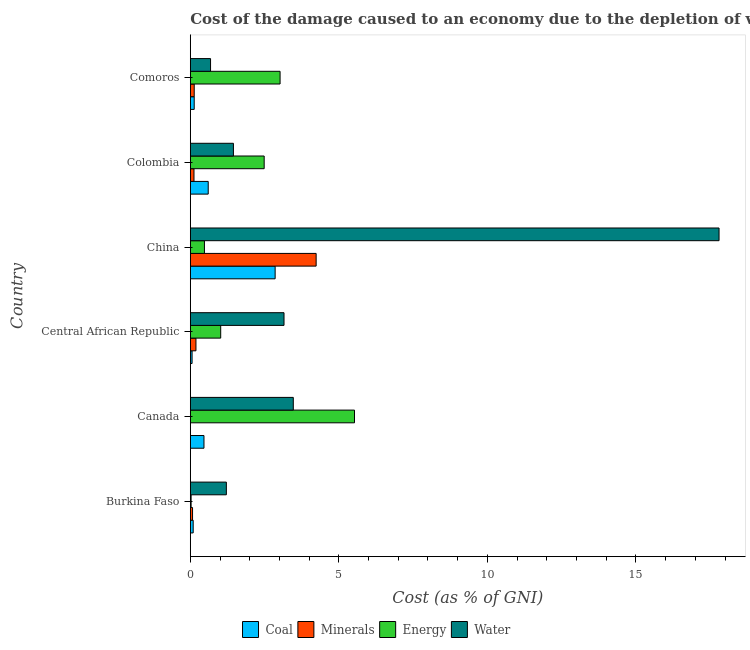How many bars are there on the 4th tick from the top?
Keep it short and to the point. 4. How many bars are there on the 3rd tick from the bottom?
Give a very brief answer. 4. What is the label of the 2nd group of bars from the top?
Your answer should be very brief. Colombia. What is the cost of damage due to depletion of minerals in Colombia?
Offer a terse response. 0.12. Across all countries, what is the maximum cost of damage due to depletion of energy?
Provide a succinct answer. 5.53. Across all countries, what is the minimum cost of damage due to depletion of energy?
Make the answer very short. 0.03. In which country was the cost of damage due to depletion of coal maximum?
Give a very brief answer. China. What is the total cost of damage due to depletion of energy in the graph?
Keep it short and to the point. 12.56. What is the difference between the cost of damage due to depletion of water in Canada and that in Colombia?
Keep it short and to the point. 2.02. What is the difference between the cost of damage due to depletion of water in Central African Republic and the cost of damage due to depletion of energy in Canada?
Keep it short and to the point. -2.37. What is the average cost of damage due to depletion of coal per country?
Make the answer very short. 0.7. What is the difference between the cost of damage due to depletion of energy and cost of damage due to depletion of water in Canada?
Ensure brevity in your answer.  2.06. What is the ratio of the cost of damage due to depletion of energy in China to that in Colombia?
Your response must be concise. 0.19. Is the difference between the cost of damage due to depletion of minerals in China and Colombia greater than the difference between the cost of damage due to depletion of water in China and Colombia?
Your answer should be compact. No. What is the difference between the highest and the second highest cost of damage due to depletion of coal?
Your answer should be compact. 2.25. What is the difference between the highest and the lowest cost of damage due to depletion of water?
Provide a short and direct response. 17.12. In how many countries, is the cost of damage due to depletion of energy greater than the average cost of damage due to depletion of energy taken over all countries?
Your answer should be very brief. 3. What does the 4th bar from the top in Comoros represents?
Offer a very short reply. Coal. What does the 4th bar from the bottom in Burkina Faso represents?
Provide a short and direct response. Water. Is it the case that in every country, the sum of the cost of damage due to depletion of coal and cost of damage due to depletion of minerals is greater than the cost of damage due to depletion of energy?
Your response must be concise. No. Are all the bars in the graph horizontal?
Your answer should be very brief. Yes. What is the difference between two consecutive major ticks on the X-axis?
Your answer should be very brief. 5. Does the graph contain any zero values?
Offer a terse response. No. How many legend labels are there?
Offer a terse response. 4. What is the title of the graph?
Keep it short and to the point. Cost of the damage caused to an economy due to the depletion of various resources in 1986 . What is the label or title of the X-axis?
Provide a short and direct response. Cost (as % of GNI). What is the label or title of the Y-axis?
Offer a terse response. Country. What is the Cost (as % of GNI) of Coal in Burkina Faso?
Your answer should be very brief. 0.1. What is the Cost (as % of GNI) in Minerals in Burkina Faso?
Provide a short and direct response. 0.08. What is the Cost (as % of GNI) in Energy in Burkina Faso?
Provide a short and direct response. 0.03. What is the Cost (as % of GNI) in Water in Burkina Faso?
Offer a very short reply. 1.21. What is the Cost (as % of GNI) in Coal in Canada?
Your answer should be very brief. 0.46. What is the Cost (as % of GNI) in Minerals in Canada?
Ensure brevity in your answer.  0. What is the Cost (as % of GNI) of Energy in Canada?
Your answer should be compact. 5.53. What is the Cost (as % of GNI) in Water in Canada?
Give a very brief answer. 3.47. What is the Cost (as % of GNI) of Coal in Central African Republic?
Offer a very short reply. 0.06. What is the Cost (as % of GNI) of Minerals in Central African Republic?
Provide a short and direct response. 0.19. What is the Cost (as % of GNI) of Energy in Central African Republic?
Keep it short and to the point. 1.02. What is the Cost (as % of GNI) in Water in Central African Republic?
Keep it short and to the point. 3.15. What is the Cost (as % of GNI) of Coal in China?
Your answer should be very brief. 2.86. What is the Cost (as % of GNI) in Minerals in China?
Your answer should be compact. 4.24. What is the Cost (as % of GNI) of Energy in China?
Keep it short and to the point. 0.48. What is the Cost (as % of GNI) in Water in China?
Offer a very short reply. 17.8. What is the Cost (as % of GNI) of Coal in Colombia?
Keep it short and to the point. 0.6. What is the Cost (as % of GNI) of Minerals in Colombia?
Your response must be concise. 0.12. What is the Cost (as % of GNI) of Energy in Colombia?
Ensure brevity in your answer.  2.49. What is the Cost (as % of GNI) of Water in Colombia?
Your response must be concise. 1.45. What is the Cost (as % of GNI) in Coal in Comoros?
Offer a very short reply. 0.13. What is the Cost (as % of GNI) of Minerals in Comoros?
Offer a terse response. 0.13. What is the Cost (as % of GNI) of Energy in Comoros?
Provide a short and direct response. 3.02. What is the Cost (as % of GNI) in Water in Comoros?
Offer a very short reply. 0.68. Across all countries, what is the maximum Cost (as % of GNI) of Coal?
Ensure brevity in your answer.  2.86. Across all countries, what is the maximum Cost (as % of GNI) in Minerals?
Offer a very short reply. 4.24. Across all countries, what is the maximum Cost (as % of GNI) of Energy?
Your response must be concise. 5.53. Across all countries, what is the maximum Cost (as % of GNI) of Water?
Your answer should be compact. 17.8. Across all countries, what is the minimum Cost (as % of GNI) of Coal?
Provide a short and direct response. 0.06. Across all countries, what is the minimum Cost (as % of GNI) of Minerals?
Offer a very short reply. 0. Across all countries, what is the minimum Cost (as % of GNI) of Energy?
Your answer should be very brief. 0.03. Across all countries, what is the minimum Cost (as % of GNI) of Water?
Make the answer very short. 0.68. What is the total Cost (as % of GNI) of Coal in the graph?
Make the answer very short. 4.21. What is the total Cost (as % of GNI) in Minerals in the graph?
Your response must be concise. 4.76. What is the total Cost (as % of GNI) in Energy in the graph?
Your response must be concise. 12.56. What is the total Cost (as % of GNI) of Water in the graph?
Your answer should be compact. 27.77. What is the difference between the Cost (as % of GNI) of Coal in Burkina Faso and that in Canada?
Offer a terse response. -0.36. What is the difference between the Cost (as % of GNI) of Minerals in Burkina Faso and that in Canada?
Offer a very short reply. 0.08. What is the difference between the Cost (as % of GNI) in Energy in Burkina Faso and that in Canada?
Offer a terse response. -5.5. What is the difference between the Cost (as % of GNI) in Water in Burkina Faso and that in Canada?
Provide a short and direct response. -2.25. What is the difference between the Cost (as % of GNI) of Coal in Burkina Faso and that in Central African Republic?
Make the answer very short. 0.04. What is the difference between the Cost (as % of GNI) in Minerals in Burkina Faso and that in Central African Republic?
Offer a very short reply. -0.11. What is the difference between the Cost (as % of GNI) of Energy in Burkina Faso and that in Central African Republic?
Your answer should be very brief. -1. What is the difference between the Cost (as % of GNI) of Water in Burkina Faso and that in Central African Republic?
Offer a terse response. -1.94. What is the difference between the Cost (as % of GNI) of Coal in Burkina Faso and that in China?
Ensure brevity in your answer.  -2.76. What is the difference between the Cost (as % of GNI) in Minerals in Burkina Faso and that in China?
Provide a short and direct response. -4.16. What is the difference between the Cost (as % of GNI) in Energy in Burkina Faso and that in China?
Ensure brevity in your answer.  -0.45. What is the difference between the Cost (as % of GNI) in Water in Burkina Faso and that in China?
Give a very brief answer. -16.58. What is the difference between the Cost (as % of GNI) in Coal in Burkina Faso and that in Colombia?
Give a very brief answer. -0.51. What is the difference between the Cost (as % of GNI) of Minerals in Burkina Faso and that in Colombia?
Offer a very short reply. -0.05. What is the difference between the Cost (as % of GNI) of Energy in Burkina Faso and that in Colombia?
Provide a short and direct response. -2.46. What is the difference between the Cost (as % of GNI) of Water in Burkina Faso and that in Colombia?
Your answer should be compact. -0.24. What is the difference between the Cost (as % of GNI) in Coal in Burkina Faso and that in Comoros?
Offer a terse response. -0.03. What is the difference between the Cost (as % of GNI) of Minerals in Burkina Faso and that in Comoros?
Keep it short and to the point. -0.06. What is the difference between the Cost (as % of GNI) of Energy in Burkina Faso and that in Comoros?
Your answer should be very brief. -2.99. What is the difference between the Cost (as % of GNI) in Water in Burkina Faso and that in Comoros?
Your response must be concise. 0.53. What is the difference between the Cost (as % of GNI) of Coal in Canada and that in Central African Republic?
Provide a succinct answer. 0.4. What is the difference between the Cost (as % of GNI) in Minerals in Canada and that in Central African Republic?
Offer a very short reply. -0.19. What is the difference between the Cost (as % of GNI) of Energy in Canada and that in Central African Republic?
Your answer should be compact. 4.5. What is the difference between the Cost (as % of GNI) in Water in Canada and that in Central African Republic?
Keep it short and to the point. 0.31. What is the difference between the Cost (as % of GNI) of Coal in Canada and that in China?
Offer a very short reply. -2.4. What is the difference between the Cost (as % of GNI) in Minerals in Canada and that in China?
Make the answer very short. -4.24. What is the difference between the Cost (as % of GNI) of Energy in Canada and that in China?
Give a very brief answer. 5.05. What is the difference between the Cost (as % of GNI) of Water in Canada and that in China?
Make the answer very short. -14.33. What is the difference between the Cost (as % of GNI) of Coal in Canada and that in Colombia?
Your answer should be very brief. -0.14. What is the difference between the Cost (as % of GNI) of Minerals in Canada and that in Colombia?
Give a very brief answer. -0.12. What is the difference between the Cost (as % of GNI) in Energy in Canada and that in Colombia?
Offer a very short reply. 3.04. What is the difference between the Cost (as % of GNI) in Water in Canada and that in Colombia?
Ensure brevity in your answer.  2.02. What is the difference between the Cost (as % of GNI) in Coal in Canada and that in Comoros?
Provide a short and direct response. 0.33. What is the difference between the Cost (as % of GNI) of Minerals in Canada and that in Comoros?
Keep it short and to the point. -0.13. What is the difference between the Cost (as % of GNI) of Energy in Canada and that in Comoros?
Make the answer very short. 2.5. What is the difference between the Cost (as % of GNI) in Water in Canada and that in Comoros?
Your response must be concise. 2.79. What is the difference between the Cost (as % of GNI) of Coal in Central African Republic and that in China?
Make the answer very short. -2.8. What is the difference between the Cost (as % of GNI) in Minerals in Central African Republic and that in China?
Ensure brevity in your answer.  -4.05. What is the difference between the Cost (as % of GNI) in Energy in Central African Republic and that in China?
Give a very brief answer. 0.55. What is the difference between the Cost (as % of GNI) in Water in Central African Republic and that in China?
Ensure brevity in your answer.  -14.64. What is the difference between the Cost (as % of GNI) in Coal in Central African Republic and that in Colombia?
Provide a short and direct response. -0.54. What is the difference between the Cost (as % of GNI) of Minerals in Central African Republic and that in Colombia?
Offer a very short reply. 0.07. What is the difference between the Cost (as % of GNI) in Energy in Central African Republic and that in Colombia?
Your answer should be very brief. -1.46. What is the difference between the Cost (as % of GNI) of Water in Central African Republic and that in Colombia?
Your answer should be compact. 1.7. What is the difference between the Cost (as % of GNI) of Coal in Central African Republic and that in Comoros?
Offer a very short reply. -0.07. What is the difference between the Cost (as % of GNI) in Minerals in Central African Republic and that in Comoros?
Ensure brevity in your answer.  0.06. What is the difference between the Cost (as % of GNI) of Energy in Central African Republic and that in Comoros?
Your answer should be compact. -2. What is the difference between the Cost (as % of GNI) of Water in Central African Republic and that in Comoros?
Your response must be concise. 2.47. What is the difference between the Cost (as % of GNI) of Coal in China and that in Colombia?
Keep it short and to the point. 2.25. What is the difference between the Cost (as % of GNI) in Minerals in China and that in Colombia?
Ensure brevity in your answer.  4.11. What is the difference between the Cost (as % of GNI) of Energy in China and that in Colombia?
Your answer should be very brief. -2.01. What is the difference between the Cost (as % of GNI) of Water in China and that in Colombia?
Offer a terse response. 16.35. What is the difference between the Cost (as % of GNI) in Coal in China and that in Comoros?
Provide a succinct answer. 2.72. What is the difference between the Cost (as % of GNI) of Minerals in China and that in Comoros?
Offer a terse response. 4.1. What is the difference between the Cost (as % of GNI) in Energy in China and that in Comoros?
Provide a short and direct response. -2.55. What is the difference between the Cost (as % of GNI) in Water in China and that in Comoros?
Give a very brief answer. 17.12. What is the difference between the Cost (as % of GNI) of Coal in Colombia and that in Comoros?
Your answer should be compact. 0.47. What is the difference between the Cost (as % of GNI) of Minerals in Colombia and that in Comoros?
Your answer should be compact. -0.01. What is the difference between the Cost (as % of GNI) of Energy in Colombia and that in Comoros?
Offer a very short reply. -0.54. What is the difference between the Cost (as % of GNI) in Water in Colombia and that in Comoros?
Offer a very short reply. 0.77. What is the difference between the Cost (as % of GNI) of Coal in Burkina Faso and the Cost (as % of GNI) of Minerals in Canada?
Provide a succinct answer. 0.1. What is the difference between the Cost (as % of GNI) in Coal in Burkina Faso and the Cost (as % of GNI) in Energy in Canada?
Give a very brief answer. -5.43. What is the difference between the Cost (as % of GNI) of Coal in Burkina Faso and the Cost (as % of GNI) of Water in Canada?
Your answer should be very brief. -3.37. What is the difference between the Cost (as % of GNI) in Minerals in Burkina Faso and the Cost (as % of GNI) in Energy in Canada?
Provide a short and direct response. -5.45. What is the difference between the Cost (as % of GNI) in Minerals in Burkina Faso and the Cost (as % of GNI) in Water in Canada?
Your answer should be very brief. -3.39. What is the difference between the Cost (as % of GNI) of Energy in Burkina Faso and the Cost (as % of GNI) of Water in Canada?
Your answer should be very brief. -3.44. What is the difference between the Cost (as % of GNI) of Coal in Burkina Faso and the Cost (as % of GNI) of Minerals in Central African Republic?
Your response must be concise. -0.09. What is the difference between the Cost (as % of GNI) in Coal in Burkina Faso and the Cost (as % of GNI) in Energy in Central African Republic?
Offer a very short reply. -0.93. What is the difference between the Cost (as % of GNI) of Coal in Burkina Faso and the Cost (as % of GNI) of Water in Central African Republic?
Your answer should be compact. -3.06. What is the difference between the Cost (as % of GNI) in Minerals in Burkina Faso and the Cost (as % of GNI) in Energy in Central African Republic?
Provide a short and direct response. -0.95. What is the difference between the Cost (as % of GNI) of Minerals in Burkina Faso and the Cost (as % of GNI) of Water in Central African Republic?
Offer a very short reply. -3.08. What is the difference between the Cost (as % of GNI) of Energy in Burkina Faso and the Cost (as % of GNI) of Water in Central African Republic?
Provide a succinct answer. -3.13. What is the difference between the Cost (as % of GNI) of Coal in Burkina Faso and the Cost (as % of GNI) of Minerals in China?
Your response must be concise. -4.14. What is the difference between the Cost (as % of GNI) of Coal in Burkina Faso and the Cost (as % of GNI) of Energy in China?
Your response must be concise. -0.38. What is the difference between the Cost (as % of GNI) in Coal in Burkina Faso and the Cost (as % of GNI) in Water in China?
Your answer should be compact. -17.7. What is the difference between the Cost (as % of GNI) of Minerals in Burkina Faso and the Cost (as % of GNI) of Energy in China?
Your response must be concise. -0.4. What is the difference between the Cost (as % of GNI) in Minerals in Burkina Faso and the Cost (as % of GNI) in Water in China?
Make the answer very short. -17.72. What is the difference between the Cost (as % of GNI) of Energy in Burkina Faso and the Cost (as % of GNI) of Water in China?
Offer a terse response. -17.77. What is the difference between the Cost (as % of GNI) in Coal in Burkina Faso and the Cost (as % of GNI) in Minerals in Colombia?
Provide a succinct answer. -0.03. What is the difference between the Cost (as % of GNI) in Coal in Burkina Faso and the Cost (as % of GNI) in Energy in Colombia?
Your answer should be very brief. -2.39. What is the difference between the Cost (as % of GNI) of Coal in Burkina Faso and the Cost (as % of GNI) of Water in Colombia?
Ensure brevity in your answer.  -1.35. What is the difference between the Cost (as % of GNI) of Minerals in Burkina Faso and the Cost (as % of GNI) of Energy in Colombia?
Make the answer very short. -2.41. What is the difference between the Cost (as % of GNI) of Minerals in Burkina Faso and the Cost (as % of GNI) of Water in Colombia?
Make the answer very short. -1.38. What is the difference between the Cost (as % of GNI) in Energy in Burkina Faso and the Cost (as % of GNI) in Water in Colombia?
Provide a short and direct response. -1.42. What is the difference between the Cost (as % of GNI) in Coal in Burkina Faso and the Cost (as % of GNI) in Minerals in Comoros?
Keep it short and to the point. -0.03. What is the difference between the Cost (as % of GNI) in Coal in Burkina Faso and the Cost (as % of GNI) in Energy in Comoros?
Your response must be concise. -2.92. What is the difference between the Cost (as % of GNI) of Coal in Burkina Faso and the Cost (as % of GNI) of Water in Comoros?
Your answer should be compact. -0.58. What is the difference between the Cost (as % of GNI) of Minerals in Burkina Faso and the Cost (as % of GNI) of Energy in Comoros?
Your answer should be very brief. -2.95. What is the difference between the Cost (as % of GNI) of Minerals in Burkina Faso and the Cost (as % of GNI) of Water in Comoros?
Keep it short and to the point. -0.61. What is the difference between the Cost (as % of GNI) of Energy in Burkina Faso and the Cost (as % of GNI) of Water in Comoros?
Offer a very short reply. -0.65. What is the difference between the Cost (as % of GNI) of Coal in Canada and the Cost (as % of GNI) of Minerals in Central African Republic?
Provide a succinct answer. 0.27. What is the difference between the Cost (as % of GNI) of Coal in Canada and the Cost (as % of GNI) of Energy in Central African Republic?
Ensure brevity in your answer.  -0.56. What is the difference between the Cost (as % of GNI) in Coal in Canada and the Cost (as % of GNI) in Water in Central African Republic?
Your answer should be compact. -2.69. What is the difference between the Cost (as % of GNI) in Minerals in Canada and the Cost (as % of GNI) in Energy in Central African Republic?
Give a very brief answer. -1.02. What is the difference between the Cost (as % of GNI) of Minerals in Canada and the Cost (as % of GNI) of Water in Central African Republic?
Your response must be concise. -3.15. What is the difference between the Cost (as % of GNI) in Energy in Canada and the Cost (as % of GNI) in Water in Central African Republic?
Make the answer very short. 2.37. What is the difference between the Cost (as % of GNI) in Coal in Canada and the Cost (as % of GNI) in Minerals in China?
Your answer should be very brief. -3.78. What is the difference between the Cost (as % of GNI) in Coal in Canada and the Cost (as % of GNI) in Energy in China?
Provide a succinct answer. -0.02. What is the difference between the Cost (as % of GNI) in Coal in Canada and the Cost (as % of GNI) in Water in China?
Provide a short and direct response. -17.34. What is the difference between the Cost (as % of GNI) of Minerals in Canada and the Cost (as % of GNI) of Energy in China?
Provide a succinct answer. -0.48. What is the difference between the Cost (as % of GNI) of Minerals in Canada and the Cost (as % of GNI) of Water in China?
Offer a terse response. -17.8. What is the difference between the Cost (as % of GNI) in Energy in Canada and the Cost (as % of GNI) in Water in China?
Make the answer very short. -12.27. What is the difference between the Cost (as % of GNI) of Coal in Canada and the Cost (as % of GNI) of Minerals in Colombia?
Keep it short and to the point. 0.34. What is the difference between the Cost (as % of GNI) of Coal in Canada and the Cost (as % of GNI) of Energy in Colombia?
Ensure brevity in your answer.  -2.03. What is the difference between the Cost (as % of GNI) of Coal in Canada and the Cost (as % of GNI) of Water in Colombia?
Offer a terse response. -0.99. What is the difference between the Cost (as % of GNI) of Minerals in Canada and the Cost (as % of GNI) of Energy in Colombia?
Provide a succinct answer. -2.49. What is the difference between the Cost (as % of GNI) of Minerals in Canada and the Cost (as % of GNI) of Water in Colombia?
Make the answer very short. -1.45. What is the difference between the Cost (as % of GNI) in Energy in Canada and the Cost (as % of GNI) in Water in Colombia?
Keep it short and to the point. 4.08. What is the difference between the Cost (as % of GNI) in Coal in Canada and the Cost (as % of GNI) in Minerals in Comoros?
Provide a short and direct response. 0.33. What is the difference between the Cost (as % of GNI) of Coal in Canada and the Cost (as % of GNI) of Energy in Comoros?
Your response must be concise. -2.56. What is the difference between the Cost (as % of GNI) in Coal in Canada and the Cost (as % of GNI) in Water in Comoros?
Your answer should be very brief. -0.22. What is the difference between the Cost (as % of GNI) of Minerals in Canada and the Cost (as % of GNI) of Energy in Comoros?
Provide a succinct answer. -3.02. What is the difference between the Cost (as % of GNI) in Minerals in Canada and the Cost (as % of GNI) in Water in Comoros?
Give a very brief answer. -0.68. What is the difference between the Cost (as % of GNI) of Energy in Canada and the Cost (as % of GNI) of Water in Comoros?
Offer a terse response. 4.85. What is the difference between the Cost (as % of GNI) of Coal in Central African Republic and the Cost (as % of GNI) of Minerals in China?
Your answer should be compact. -4.18. What is the difference between the Cost (as % of GNI) of Coal in Central African Republic and the Cost (as % of GNI) of Energy in China?
Keep it short and to the point. -0.42. What is the difference between the Cost (as % of GNI) of Coal in Central African Republic and the Cost (as % of GNI) of Water in China?
Give a very brief answer. -17.74. What is the difference between the Cost (as % of GNI) of Minerals in Central African Republic and the Cost (as % of GNI) of Energy in China?
Give a very brief answer. -0.29. What is the difference between the Cost (as % of GNI) in Minerals in Central African Republic and the Cost (as % of GNI) in Water in China?
Provide a short and direct response. -17.61. What is the difference between the Cost (as % of GNI) of Energy in Central African Republic and the Cost (as % of GNI) of Water in China?
Offer a terse response. -16.77. What is the difference between the Cost (as % of GNI) of Coal in Central African Republic and the Cost (as % of GNI) of Minerals in Colombia?
Provide a succinct answer. -0.06. What is the difference between the Cost (as % of GNI) in Coal in Central African Republic and the Cost (as % of GNI) in Energy in Colombia?
Keep it short and to the point. -2.43. What is the difference between the Cost (as % of GNI) of Coal in Central African Republic and the Cost (as % of GNI) of Water in Colombia?
Your response must be concise. -1.39. What is the difference between the Cost (as % of GNI) in Minerals in Central African Republic and the Cost (as % of GNI) in Energy in Colombia?
Provide a succinct answer. -2.3. What is the difference between the Cost (as % of GNI) in Minerals in Central African Republic and the Cost (as % of GNI) in Water in Colombia?
Offer a terse response. -1.26. What is the difference between the Cost (as % of GNI) of Energy in Central African Republic and the Cost (as % of GNI) of Water in Colombia?
Keep it short and to the point. -0.43. What is the difference between the Cost (as % of GNI) in Coal in Central African Republic and the Cost (as % of GNI) in Minerals in Comoros?
Your answer should be compact. -0.07. What is the difference between the Cost (as % of GNI) in Coal in Central African Republic and the Cost (as % of GNI) in Energy in Comoros?
Keep it short and to the point. -2.96. What is the difference between the Cost (as % of GNI) of Coal in Central African Republic and the Cost (as % of GNI) of Water in Comoros?
Make the answer very short. -0.62. What is the difference between the Cost (as % of GNI) in Minerals in Central African Republic and the Cost (as % of GNI) in Energy in Comoros?
Your response must be concise. -2.83. What is the difference between the Cost (as % of GNI) in Minerals in Central African Republic and the Cost (as % of GNI) in Water in Comoros?
Offer a terse response. -0.49. What is the difference between the Cost (as % of GNI) of Energy in Central African Republic and the Cost (as % of GNI) of Water in Comoros?
Provide a succinct answer. 0.34. What is the difference between the Cost (as % of GNI) of Coal in China and the Cost (as % of GNI) of Minerals in Colombia?
Provide a short and direct response. 2.73. What is the difference between the Cost (as % of GNI) of Coal in China and the Cost (as % of GNI) of Energy in Colombia?
Your answer should be compact. 0.37. What is the difference between the Cost (as % of GNI) in Coal in China and the Cost (as % of GNI) in Water in Colombia?
Your answer should be compact. 1.4. What is the difference between the Cost (as % of GNI) of Minerals in China and the Cost (as % of GNI) of Energy in Colombia?
Make the answer very short. 1.75. What is the difference between the Cost (as % of GNI) in Minerals in China and the Cost (as % of GNI) in Water in Colombia?
Make the answer very short. 2.78. What is the difference between the Cost (as % of GNI) in Energy in China and the Cost (as % of GNI) in Water in Colombia?
Give a very brief answer. -0.98. What is the difference between the Cost (as % of GNI) of Coal in China and the Cost (as % of GNI) of Minerals in Comoros?
Offer a very short reply. 2.72. What is the difference between the Cost (as % of GNI) in Coal in China and the Cost (as % of GNI) in Energy in Comoros?
Make the answer very short. -0.17. What is the difference between the Cost (as % of GNI) in Coal in China and the Cost (as % of GNI) in Water in Comoros?
Provide a succinct answer. 2.17. What is the difference between the Cost (as % of GNI) of Minerals in China and the Cost (as % of GNI) of Energy in Comoros?
Your answer should be compact. 1.21. What is the difference between the Cost (as % of GNI) in Minerals in China and the Cost (as % of GNI) in Water in Comoros?
Make the answer very short. 3.55. What is the difference between the Cost (as % of GNI) in Energy in China and the Cost (as % of GNI) in Water in Comoros?
Provide a short and direct response. -0.21. What is the difference between the Cost (as % of GNI) of Coal in Colombia and the Cost (as % of GNI) of Minerals in Comoros?
Ensure brevity in your answer.  0.47. What is the difference between the Cost (as % of GNI) of Coal in Colombia and the Cost (as % of GNI) of Energy in Comoros?
Keep it short and to the point. -2.42. What is the difference between the Cost (as % of GNI) in Coal in Colombia and the Cost (as % of GNI) in Water in Comoros?
Ensure brevity in your answer.  -0.08. What is the difference between the Cost (as % of GNI) in Minerals in Colombia and the Cost (as % of GNI) in Energy in Comoros?
Make the answer very short. -2.9. What is the difference between the Cost (as % of GNI) of Minerals in Colombia and the Cost (as % of GNI) of Water in Comoros?
Offer a very short reply. -0.56. What is the difference between the Cost (as % of GNI) of Energy in Colombia and the Cost (as % of GNI) of Water in Comoros?
Keep it short and to the point. 1.81. What is the average Cost (as % of GNI) in Coal per country?
Offer a terse response. 0.7. What is the average Cost (as % of GNI) of Minerals per country?
Provide a succinct answer. 0.79. What is the average Cost (as % of GNI) in Energy per country?
Offer a terse response. 2.09. What is the average Cost (as % of GNI) of Water per country?
Give a very brief answer. 4.63. What is the difference between the Cost (as % of GNI) of Coal and Cost (as % of GNI) of Minerals in Burkina Faso?
Give a very brief answer. 0.02. What is the difference between the Cost (as % of GNI) of Coal and Cost (as % of GNI) of Energy in Burkina Faso?
Provide a short and direct response. 0.07. What is the difference between the Cost (as % of GNI) in Coal and Cost (as % of GNI) in Water in Burkina Faso?
Provide a succinct answer. -1.12. What is the difference between the Cost (as % of GNI) in Minerals and Cost (as % of GNI) in Energy in Burkina Faso?
Your answer should be compact. 0.05. What is the difference between the Cost (as % of GNI) in Minerals and Cost (as % of GNI) in Water in Burkina Faso?
Offer a very short reply. -1.14. What is the difference between the Cost (as % of GNI) in Energy and Cost (as % of GNI) in Water in Burkina Faso?
Offer a terse response. -1.19. What is the difference between the Cost (as % of GNI) in Coal and Cost (as % of GNI) in Minerals in Canada?
Ensure brevity in your answer.  0.46. What is the difference between the Cost (as % of GNI) in Coal and Cost (as % of GNI) in Energy in Canada?
Offer a terse response. -5.07. What is the difference between the Cost (as % of GNI) of Coal and Cost (as % of GNI) of Water in Canada?
Provide a short and direct response. -3.01. What is the difference between the Cost (as % of GNI) of Minerals and Cost (as % of GNI) of Energy in Canada?
Offer a terse response. -5.53. What is the difference between the Cost (as % of GNI) of Minerals and Cost (as % of GNI) of Water in Canada?
Your answer should be compact. -3.47. What is the difference between the Cost (as % of GNI) in Energy and Cost (as % of GNI) in Water in Canada?
Ensure brevity in your answer.  2.06. What is the difference between the Cost (as % of GNI) of Coal and Cost (as % of GNI) of Minerals in Central African Republic?
Give a very brief answer. -0.13. What is the difference between the Cost (as % of GNI) of Coal and Cost (as % of GNI) of Energy in Central African Republic?
Your answer should be compact. -0.96. What is the difference between the Cost (as % of GNI) of Coal and Cost (as % of GNI) of Water in Central African Republic?
Your answer should be very brief. -3.09. What is the difference between the Cost (as % of GNI) of Minerals and Cost (as % of GNI) of Energy in Central African Republic?
Your answer should be very brief. -0.83. What is the difference between the Cost (as % of GNI) in Minerals and Cost (as % of GNI) in Water in Central African Republic?
Keep it short and to the point. -2.96. What is the difference between the Cost (as % of GNI) in Energy and Cost (as % of GNI) in Water in Central African Republic?
Give a very brief answer. -2.13. What is the difference between the Cost (as % of GNI) of Coal and Cost (as % of GNI) of Minerals in China?
Your answer should be very brief. -1.38. What is the difference between the Cost (as % of GNI) in Coal and Cost (as % of GNI) in Energy in China?
Make the answer very short. 2.38. What is the difference between the Cost (as % of GNI) in Coal and Cost (as % of GNI) in Water in China?
Keep it short and to the point. -14.94. What is the difference between the Cost (as % of GNI) in Minerals and Cost (as % of GNI) in Energy in China?
Provide a succinct answer. 3.76. What is the difference between the Cost (as % of GNI) of Minerals and Cost (as % of GNI) of Water in China?
Make the answer very short. -13.56. What is the difference between the Cost (as % of GNI) of Energy and Cost (as % of GNI) of Water in China?
Provide a succinct answer. -17.32. What is the difference between the Cost (as % of GNI) of Coal and Cost (as % of GNI) of Minerals in Colombia?
Offer a terse response. 0.48. What is the difference between the Cost (as % of GNI) in Coal and Cost (as % of GNI) in Energy in Colombia?
Provide a short and direct response. -1.88. What is the difference between the Cost (as % of GNI) in Coal and Cost (as % of GNI) in Water in Colombia?
Give a very brief answer. -0.85. What is the difference between the Cost (as % of GNI) of Minerals and Cost (as % of GNI) of Energy in Colombia?
Give a very brief answer. -2.36. What is the difference between the Cost (as % of GNI) in Minerals and Cost (as % of GNI) in Water in Colombia?
Offer a very short reply. -1.33. What is the difference between the Cost (as % of GNI) of Energy and Cost (as % of GNI) of Water in Colombia?
Provide a short and direct response. 1.04. What is the difference between the Cost (as % of GNI) in Coal and Cost (as % of GNI) in Minerals in Comoros?
Offer a terse response. -0. What is the difference between the Cost (as % of GNI) in Coal and Cost (as % of GNI) in Energy in Comoros?
Ensure brevity in your answer.  -2.89. What is the difference between the Cost (as % of GNI) in Coal and Cost (as % of GNI) in Water in Comoros?
Give a very brief answer. -0.55. What is the difference between the Cost (as % of GNI) in Minerals and Cost (as % of GNI) in Energy in Comoros?
Provide a succinct answer. -2.89. What is the difference between the Cost (as % of GNI) in Minerals and Cost (as % of GNI) in Water in Comoros?
Ensure brevity in your answer.  -0.55. What is the difference between the Cost (as % of GNI) in Energy and Cost (as % of GNI) in Water in Comoros?
Offer a terse response. 2.34. What is the ratio of the Cost (as % of GNI) of Coal in Burkina Faso to that in Canada?
Offer a very short reply. 0.21. What is the ratio of the Cost (as % of GNI) in Minerals in Burkina Faso to that in Canada?
Provide a succinct answer. 649.97. What is the ratio of the Cost (as % of GNI) of Energy in Burkina Faso to that in Canada?
Keep it short and to the point. 0. What is the ratio of the Cost (as % of GNI) of Water in Burkina Faso to that in Canada?
Keep it short and to the point. 0.35. What is the ratio of the Cost (as % of GNI) of Coal in Burkina Faso to that in Central African Republic?
Ensure brevity in your answer.  1.63. What is the ratio of the Cost (as % of GNI) of Minerals in Burkina Faso to that in Central African Republic?
Offer a very short reply. 0.4. What is the ratio of the Cost (as % of GNI) of Energy in Burkina Faso to that in Central African Republic?
Give a very brief answer. 0.03. What is the ratio of the Cost (as % of GNI) in Water in Burkina Faso to that in Central African Republic?
Keep it short and to the point. 0.38. What is the ratio of the Cost (as % of GNI) of Coal in Burkina Faso to that in China?
Provide a succinct answer. 0.03. What is the ratio of the Cost (as % of GNI) in Minerals in Burkina Faso to that in China?
Your answer should be compact. 0.02. What is the ratio of the Cost (as % of GNI) in Energy in Burkina Faso to that in China?
Your answer should be compact. 0.06. What is the ratio of the Cost (as % of GNI) of Water in Burkina Faso to that in China?
Offer a terse response. 0.07. What is the ratio of the Cost (as % of GNI) in Coal in Burkina Faso to that in Colombia?
Your response must be concise. 0.16. What is the ratio of the Cost (as % of GNI) in Minerals in Burkina Faso to that in Colombia?
Make the answer very short. 0.61. What is the ratio of the Cost (as % of GNI) in Energy in Burkina Faso to that in Colombia?
Give a very brief answer. 0.01. What is the ratio of the Cost (as % of GNI) in Water in Burkina Faso to that in Colombia?
Ensure brevity in your answer.  0.84. What is the ratio of the Cost (as % of GNI) of Coal in Burkina Faso to that in Comoros?
Make the answer very short. 0.74. What is the ratio of the Cost (as % of GNI) in Minerals in Burkina Faso to that in Comoros?
Ensure brevity in your answer.  0.57. What is the ratio of the Cost (as % of GNI) of Energy in Burkina Faso to that in Comoros?
Your answer should be compact. 0.01. What is the ratio of the Cost (as % of GNI) of Water in Burkina Faso to that in Comoros?
Provide a succinct answer. 1.78. What is the ratio of the Cost (as % of GNI) in Coal in Canada to that in Central African Republic?
Provide a short and direct response. 7.68. What is the ratio of the Cost (as % of GNI) of Minerals in Canada to that in Central African Republic?
Your response must be concise. 0. What is the ratio of the Cost (as % of GNI) in Energy in Canada to that in Central African Republic?
Provide a succinct answer. 5.4. What is the ratio of the Cost (as % of GNI) in Water in Canada to that in Central African Republic?
Your answer should be very brief. 1.1. What is the ratio of the Cost (as % of GNI) of Coal in Canada to that in China?
Offer a terse response. 0.16. What is the ratio of the Cost (as % of GNI) of Minerals in Canada to that in China?
Provide a succinct answer. 0. What is the ratio of the Cost (as % of GNI) in Energy in Canada to that in China?
Your response must be concise. 11.61. What is the ratio of the Cost (as % of GNI) in Water in Canada to that in China?
Offer a terse response. 0.19. What is the ratio of the Cost (as % of GNI) in Coal in Canada to that in Colombia?
Ensure brevity in your answer.  0.76. What is the ratio of the Cost (as % of GNI) in Minerals in Canada to that in Colombia?
Your response must be concise. 0. What is the ratio of the Cost (as % of GNI) in Energy in Canada to that in Colombia?
Offer a very short reply. 2.22. What is the ratio of the Cost (as % of GNI) in Water in Canada to that in Colombia?
Keep it short and to the point. 2.39. What is the ratio of the Cost (as % of GNI) of Coal in Canada to that in Comoros?
Your answer should be very brief. 3.5. What is the ratio of the Cost (as % of GNI) in Minerals in Canada to that in Comoros?
Provide a succinct answer. 0. What is the ratio of the Cost (as % of GNI) of Energy in Canada to that in Comoros?
Offer a very short reply. 1.83. What is the ratio of the Cost (as % of GNI) of Water in Canada to that in Comoros?
Provide a short and direct response. 5.09. What is the ratio of the Cost (as % of GNI) of Coal in Central African Republic to that in China?
Keep it short and to the point. 0.02. What is the ratio of the Cost (as % of GNI) of Minerals in Central African Republic to that in China?
Offer a very short reply. 0.04. What is the ratio of the Cost (as % of GNI) of Energy in Central African Republic to that in China?
Your answer should be very brief. 2.15. What is the ratio of the Cost (as % of GNI) in Water in Central African Republic to that in China?
Offer a very short reply. 0.18. What is the ratio of the Cost (as % of GNI) in Coal in Central African Republic to that in Colombia?
Provide a succinct answer. 0.1. What is the ratio of the Cost (as % of GNI) in Minerals in Central African Republic to that in Colombia?
Make the answer very short. 1.54. What is the ratio of the Cost (as % of GNI) of Energy in Central African Republic to that in Colombia?
Your answer should be compact. 0.41. What is the ratio of the Cost (as % of GNI) of Water in Central African Republic to that in Colombia?
Provide a succinct answer. 2.17. What is the ratio of the Cost (as % of GNI) of Coal in Central African Republic to that in Comoros?
Provide a succinct answer. 0.46. What is the ratio of the Cost (as % of GNI) in Minerals in Central African Republic to that in Comoros?
Your answer should be very brief. 1.44. What is the ratio of the Cost (as % of GNI) in Energy in Central African Republic to that in Comoros?
Offer a terse response. 0.34. What is the ratio of the Cost (as % of GNI) of Water in Central African Republic to that in Comoros?
Your answer should be very brief. 4.63. What is the ratio of the Cost (as % of GNI) of Coal in China to that in Colombia?
Your answer should be compact. 4.73. What is the ratio of the Cost (as % of GNI) in Minerals in China to that in Colombia?
Keep it short and to the point. 34.14. What is the ratio of the Cost (as % of GNI) of Energy in China to that in Colombia?
Provide a succinct answer. 0.19. What is the ratio of the Cost (as % of GNI) of Water in China to that in Colombia?
Give a very brief answer. 12.26. What is the ratio of the Cost (as % of GNI) of Coal in China to that in Comoros?
Your answer should be very brief. 21.71. What is the ratio of the Cost (as % of GNI) in Minerals in China to that in Comoros?
Offer a terse response. 32.04. What is the ratio of the Cost (as % of GNI) in Energy in China to that in Comoros?
Offer a very short reply. 0.16. What is the ratio of the Cost (as % of GNI) of Water in China to that in Comoros?
Offer a very short reply. 26.11. What is the ratio of the Cost (as % of GNI) of Coal in Colombia to that in Comoros?
Ensure brevity in your answer.  4.59. What is the ratio of the Cost (as % of GNI) of Minerals in Colombia to that in Comoros?
Your answer should be compact. 0.94. What is the ratio of the Cost (as % of GNI) of Energy in Colombia to that in Comoros?
Your answer should be compact. 0.82. What is the ratio of the Cost (as % of GNI) of Water in Colombia to that in Comoros?
Provide a succinct answer. 2.13. What is the difference between the highest and the second highest Cost (as % of GNI) in Coal?
Your answer should be very brief. 2.25. What is the difference between the highest and the second highest Cost (as % of GNI) in Minerals?
Ensure brevity in your answer.  4.05. What is the difference between the highest and the second highest Cost (as % of GNI) of Energy?
Your answer should be very brief. 2.5. What is the difference between the highest and the second highest Cost (as % of GNI) of Water?
Keep it short and to the point. 14.33. What is the difference between the highest and the lowest Cost (as % of GNI) in Coal?
Give a very brief answer. 2.8. What is the difference between the highest and the lowest Cost (as % of GNI) of Minerals?
Ensure brevity in your answer.  4.24. What is the difference between the highest and the lowest Cost (as % of GNI) in Energy?
Your answer should be very brief. 5.5. What is the difference between the highest and the lowest Cost (as % of GNI) in Water?
Make the answer very short. 17.12. 